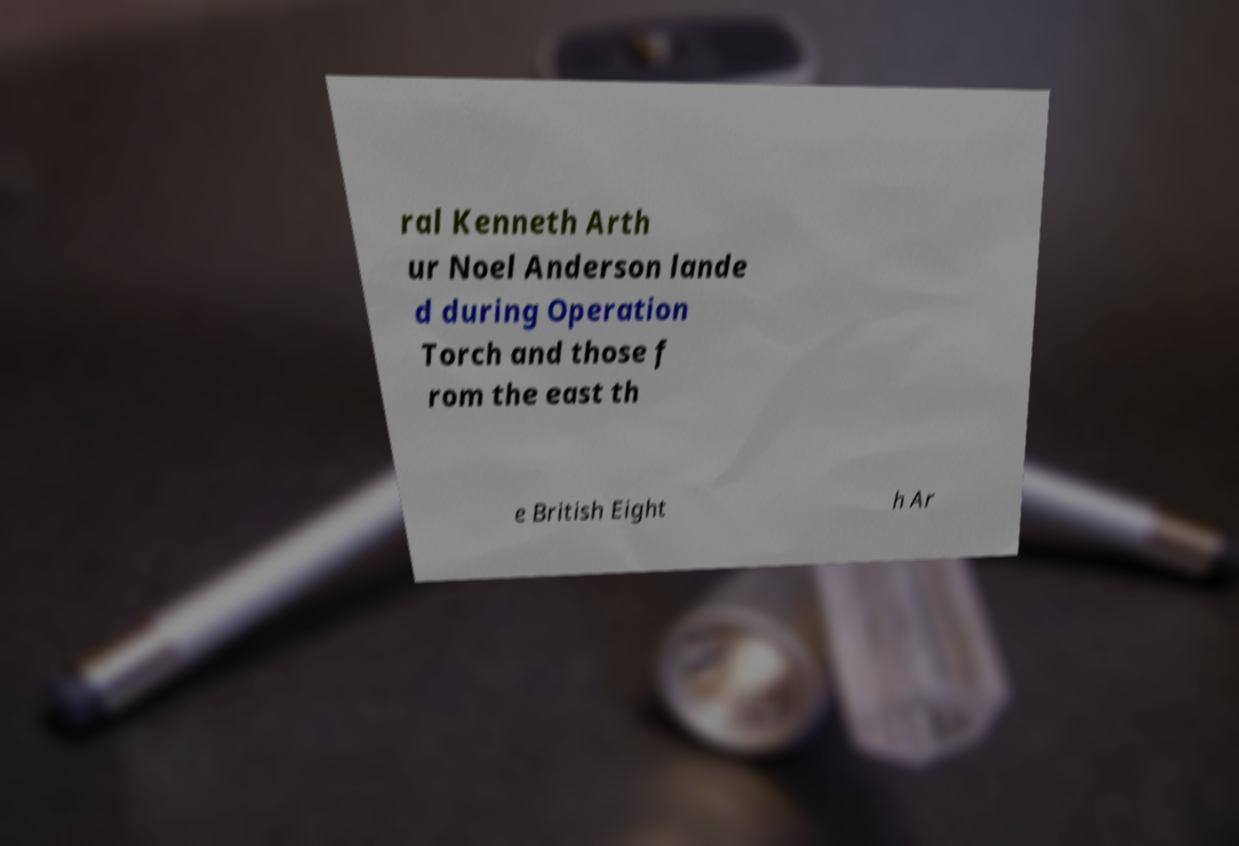Could you extract and type out the text from this image? ral Kenneth Arth ur Noel Anderson lande d during Operation Torch and those f rom the east th e British Eight h Ar 